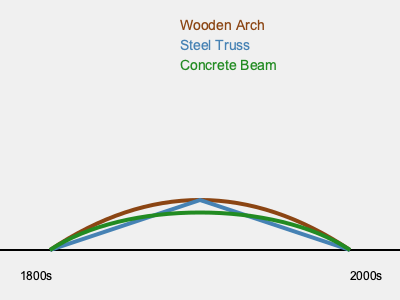Based on the schematic diagram showing the evolution of bridge designs in the Murnau am Staffelsee region, which type of bridge design became prominent in the mid-20th century and why? 1. The diagram shows three main bridge designs evolving over time from the 1800s to the 2000s:
   a) Wooden Arch (brown curve)
   b) Steel Truss (blue straight lines)
   c) Concrete Beam (green curve)

2. The Steel Truss design is represented by straight lines in the middle of the timeline, indicating its prominence in the mid-20th century.

3. Steel truss bridges became popular in the mid-20th century for several reasons:
   a) Increased strength and load-bearing capacity compared to wooden structures
   b) Ability to span longer distances
   c) Industrialization leading to more efficient steel production
   d) Improved engineering techniques for designing and constructing steel structures

4. The transition from wooden arch to steel truss bridges reflects the region's economic and technological development during this period.

5. Later in the timeline, we see the introduction of concrete beam bridges, which became more common in the late 20th and early 21st centuries due to their durability and lower maintenance requirements.
Answer: Steel Truss; increased strength, longer spans, and industrial advancements 